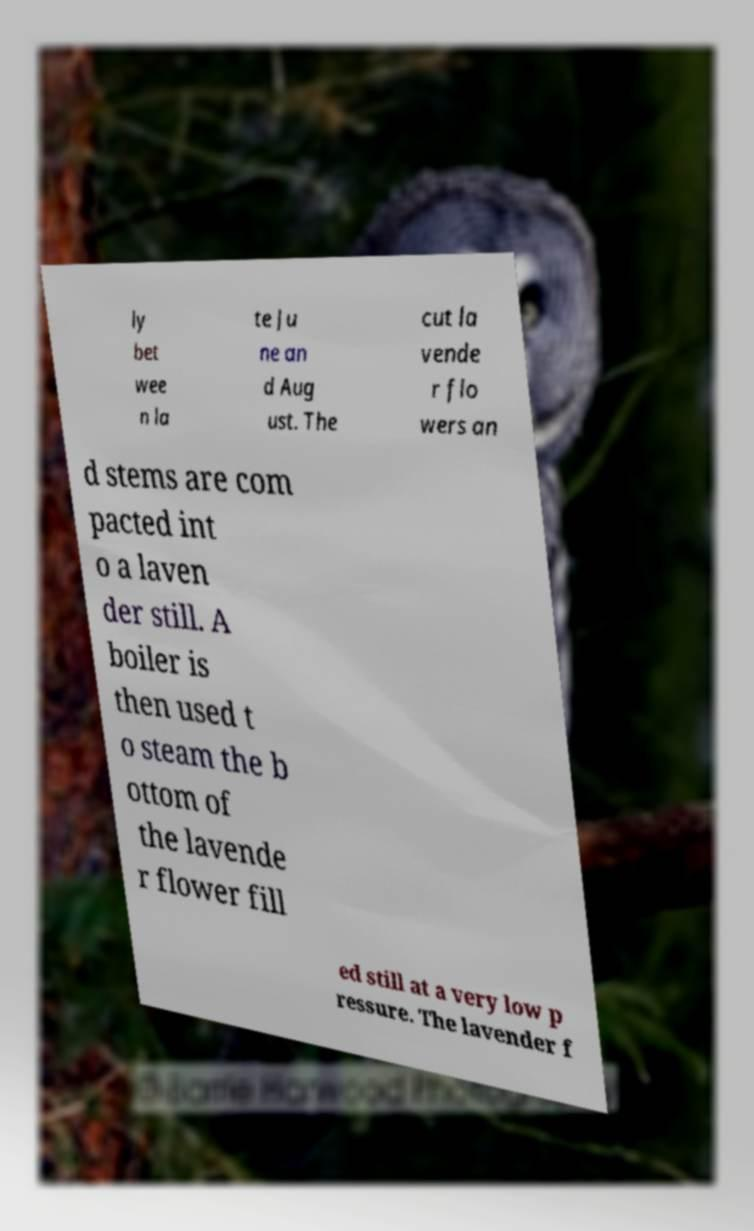I need the written content from this picture converted into text. Can you do that? ly bet wee n la te Ju ne an d Aug ust. The cut la vende r flo wers an d stems are com pacted int o a laven der still. A boiler is then used t o steam the b ottom of the lavende r flower fill ed still at a very low p ressure. The lavender f 